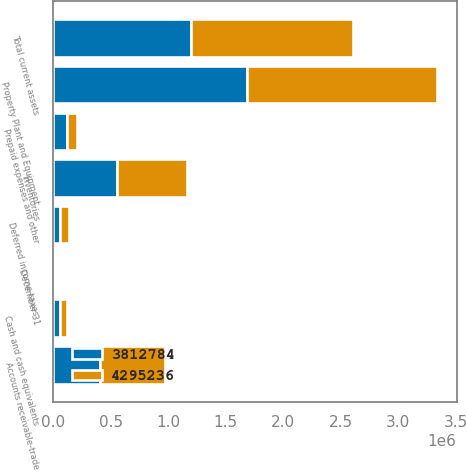Convert chart. <chart><loc_0><loc_0><loc_500><loc_500><stacked_bar_chart><ecel><fcel>December 31<fcel>Cash and cash equivalents<fcel>Accounts receivable-trade<fcel>Inventories<fcel>Deferred income taxes<fcel>Prepaid expenses and other<fcel>Total current assets<fcel>Property Plant and Equipment<nl><fcel>4.29524e+06<fcel>2005<fcel>67183<fcel>559289<fcel>610284<fcel>78196<fcel>93988<fcel>1.40894e+06<fcel>1.65914e+06<nl><fcel>3.81278e+06<fcel>2004<fcel>54837<fcel>408930<fcel>557180<fcel>61756<fcel>114991<fcel>1.19769e+06<fcel>1.6827e+06<nl></chart> 